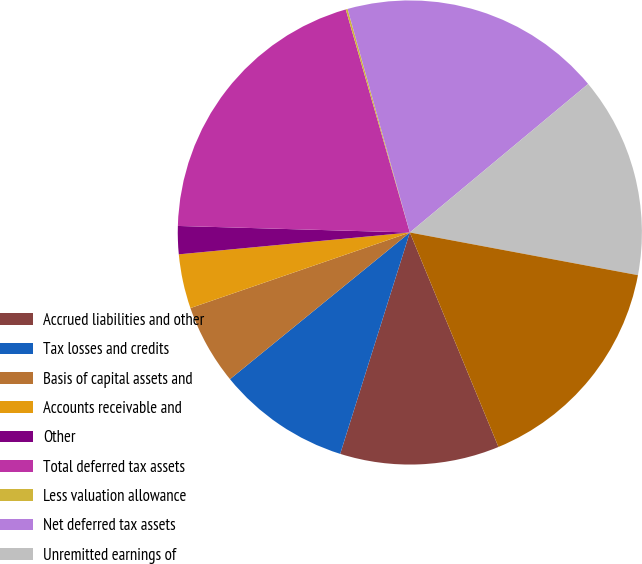Convert chart. <chart><loc_0><loc_0><loc_500><loc_500><pie_chart><fcel>Accrued liabilities and other<fcel>Tax losses and credits<fcel>Basis of capital assets and<fcel>Accounts receivable and<fcel>Other<fcel>Total deferred tax assets<fcel>Less valuation allowance<fcel>Net deferred tax assets<fcel>Unremitted earnings of<fcel>Total deferred tax liabilities<nl><fcel>11.09%<fcel>9.26%<fcel>5.61%<fcel>3.78%<fcel>1.95%<fcel>20.1%<fcel>0.13%<fcel>18.27%<fcel>14.0%<fcel>15.82%<nl></chart> 